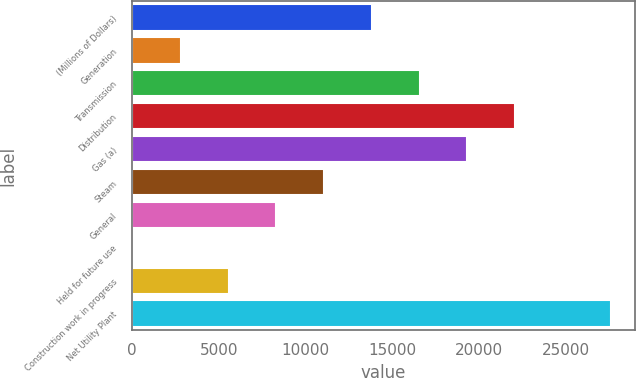Convert chart to OTSL. <chart><loc_0><loc_0><loc_500><loc_500><bar_chart><fcel>(Millions of Dollars)<fcel>Generation<fcel>Transmission<fcel>Distribution<fcel>Gas (a)<fcel>Steam<fcel>General<fcel>Held for future use<fcel>Construction work in progress<fcel>Net Utility Plant<nl><fcel>13825<fcel>2817<fcel>16577<fcel>22081<fcel>19329<fcel>11073<fcel>8321<fcel>65<fcel>5569<fcel>27585<nl></chart> 